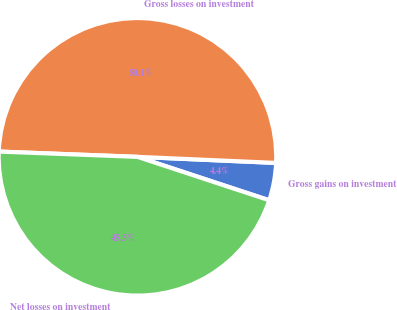Convert chart. <chart><loc_0><loc_0><loc_500><loc_500><pie_chart><fcel>Gross gains on investment<fcel>Gross losses on investment<fcel>Net losses on investment<nl><fcel>4.37%<fcel>50.09%<fcel>45.54%<nl></chart> 